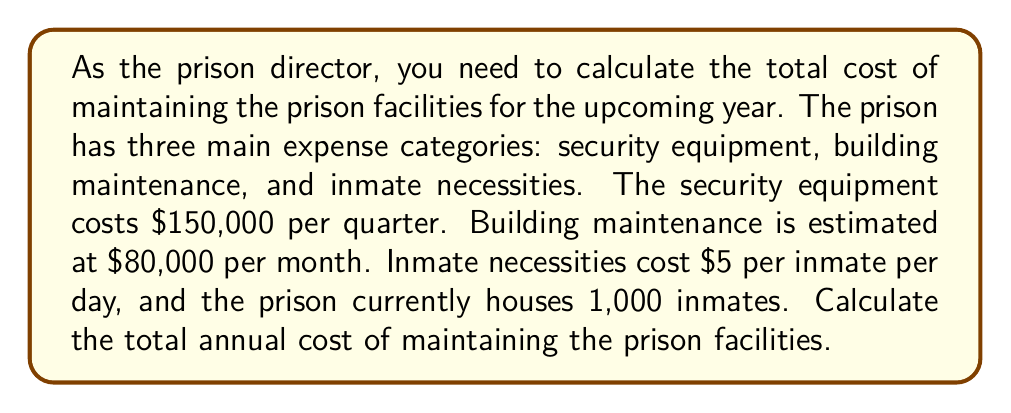Solve this math problem. To solve this problem, we need to calculate the annual cost for each category and then sum them up:

1. Security equipment:
   $$\text{Annual cost} = \text{Quarterly cost} \times 4\text{ quarters}$$
   $$150,000 \times 4 = $600,000$$

2. Building maintenance:
   $$\text{Annual cost} = \text{Monthly cost} \times 12\text{ months}$$
   $$80,000 \times 12 = $960,000$$

3. Inmate necessities:
   $$\text{Annual cost} = \text{Daily cost per inmate} \times \text{Number of inmates} \times 365\text{ days}$$
   $$5 \times 1,000 \times 365 = $1,825,000$$

Now, we sum up all three categories:
$$\text{Total annual cost} = \text{Security} + \text{Maintenance} + \text{Inmate necessities}$$
$$600,000 + 960,000 + 1,825,000 = $3,385,000$$
Answer: $3,385,000 